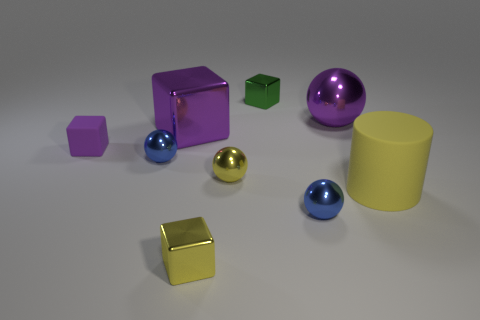Subtract all gray balls. Subtract all blue cubes. How many balls are left? 4 Subtract all cylinders. How many objects are left? 8 Add 1 yellow shiny balls. How many yellow shiny balls are left? 2 Add 6 large matte cylinders. How many large matte cylinders exist? 7 Subtract 0 cyan spheres. How many objects are left? 9 Subtract all big shiny cylinders. Subtract all green objects. How many objects are left? 8 